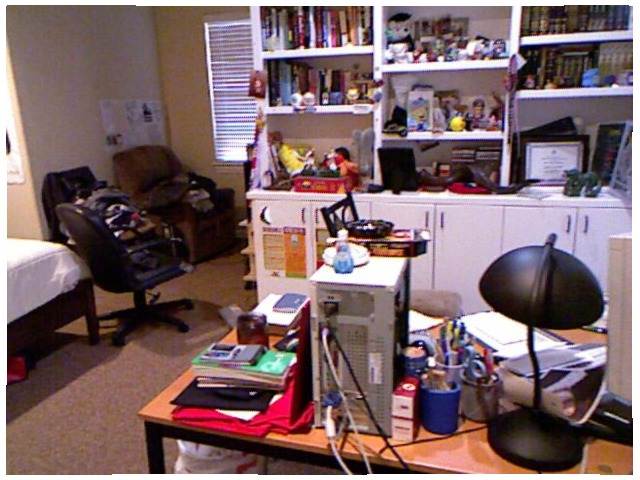<image>
Is there a book on the shelf? Yes. Looking at the image, I can see the book is positioned on top of the shelf, with the shelf providing support. Is there a papers behind the lamp? Yes. From this viewpoint, the papers is positioned behind the lamp, with the lamp partially or fully occluding the papers. 